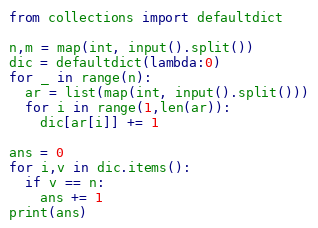<code> <loc_0><loc_0><loc_500><loc_500><_Python_>from collections import defaultdict

n,m = map(int, input().split())
dic = defaultdict(lambda:0)
for _ in range(n):
  ar = list(map(int, input().split()))
  for i in range(1,len(ar)):
    dic[ar[i]] += 1

ans = 0
for i,v in dic.items():
  if v == n:
    ans += 1
print(ans)</code> 